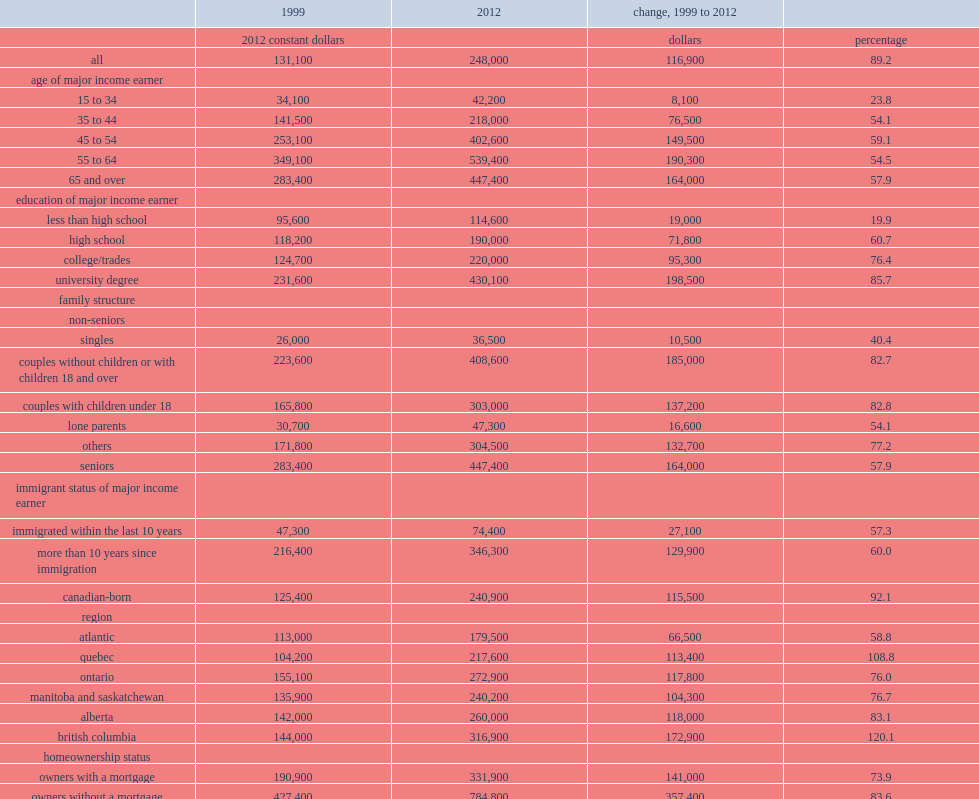What was the median net worth of all canadian families with debt in 2012? 248000.0. What was the median net worth of all canadian families with debt in 1999? 131100.0. 